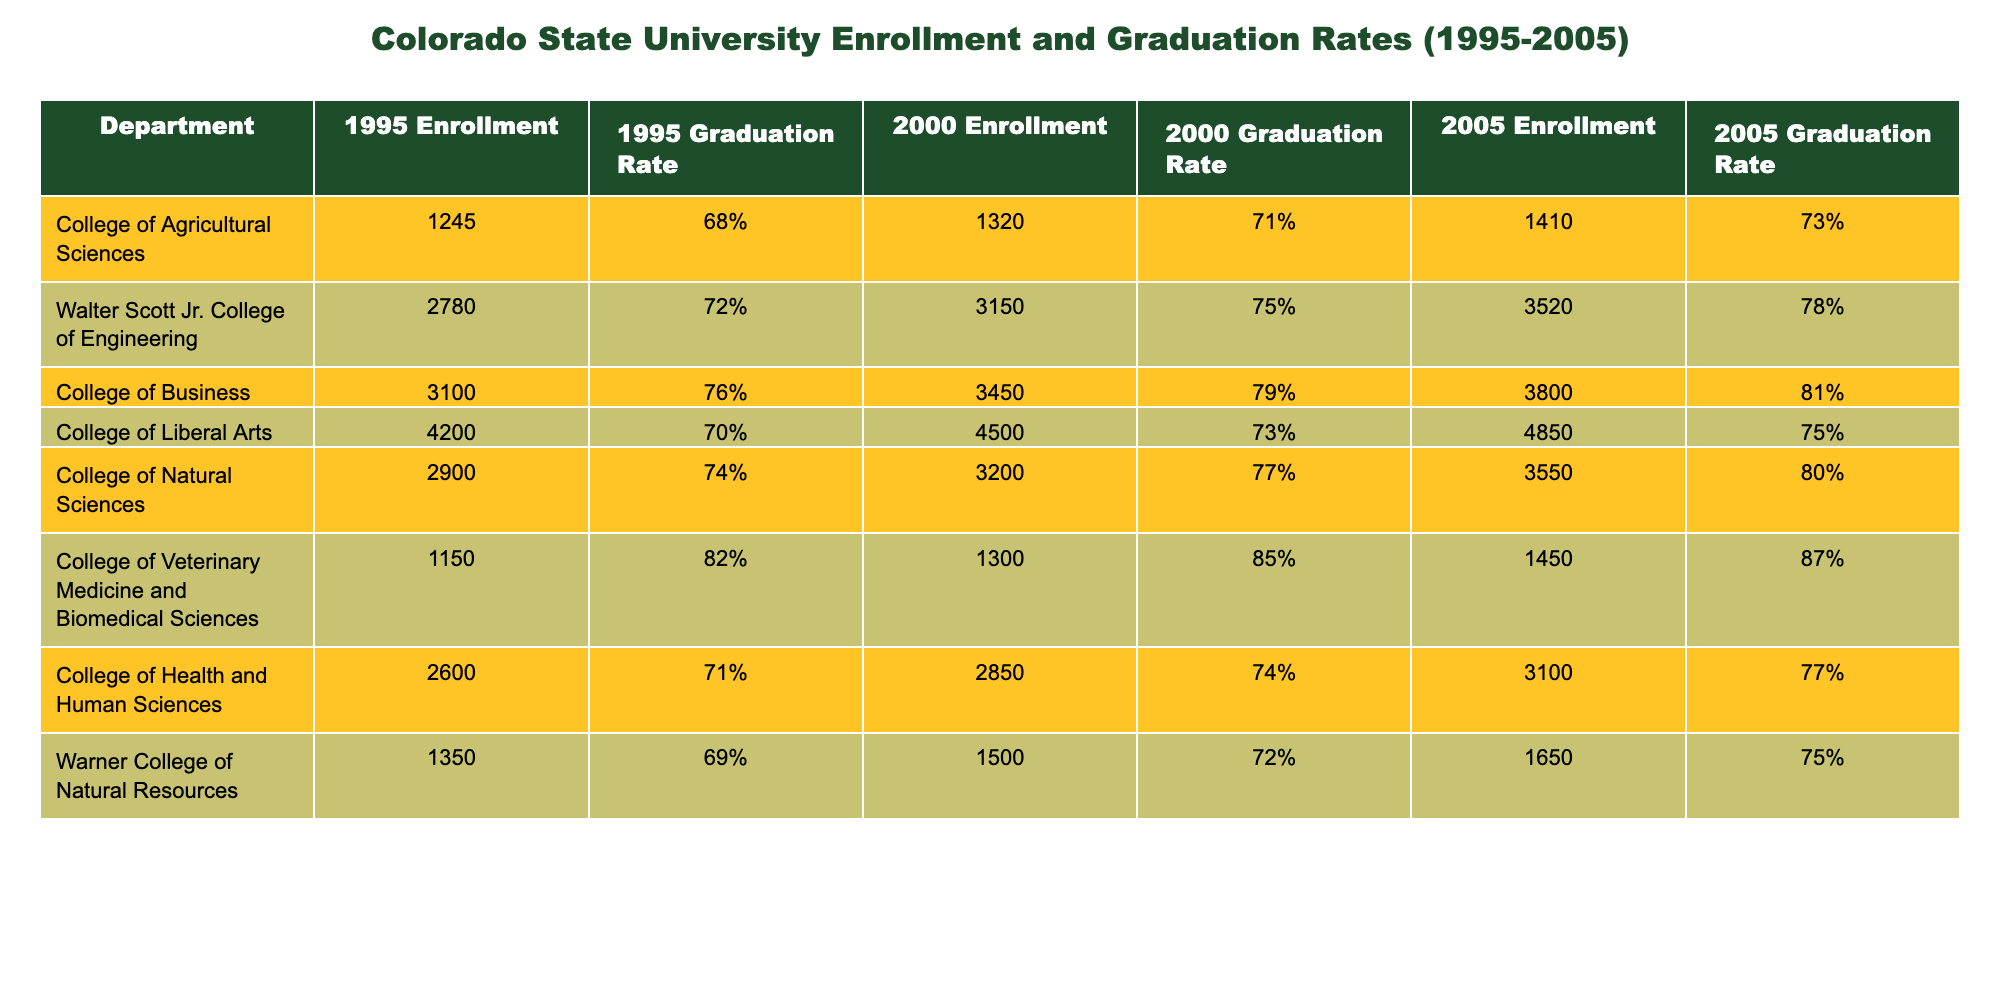What was the enrollment in the College of Business in 2000? The table shows that the enrollment for the College of Business in 2000 is listed under the column for 2000 Enrollment. It states 3450.
Answer: 3450 Which department had the highest graduation rate in 2005? To find the highest graduation rate in 2005, I look at the column for the 2005 Graduation Rate and compare the values. The College of Veterinary Medicine and Biomedical Sciences has a graduation rate of 87%, which is the highest.
Answer: College of Veterinary Medicine and Biomedical Sciences What is the percentage increase in enrollment for the Walter Scott Jr. College of Engineering from 1995 to 2005? First, I take the enrollment numbers: 2780 in 1995 and 3520 in 2005. To calculate the increase, I subtract 2780 from 3520, which gives 740. Then, I divide by the original number (2780) and multiply by 100 to get the percentage: (740 / 2780) * 100 ≈ 26.6%.
Answer: Approximately 26.6% Did the College of Health and Human Sciences have a higher graduation rate in 2000 or in 2005? The graduation rates for the College of Health and Human Sciences are 74% in 2000 and 77% in 2005. Since 77% is greater than 74%, the graduation rate was higher in 2005.
Answer: Yes, higher in 2005 What is the average graduation rate across all departments in 2005? I extract the graduation rates for 2005 from each department: 73%, 78%, 81%, 75%, 80%, 87%, 77%, and 75%. To find the average, I sum these percentages: 73 + 78 + 81 + 75 + 80 + 87 + 77 + 75 = 606. Then, I divide by the number of departments (8): 606 / 8 = 75.75%.
Answer: 75.75% Is it true that the College of Liberal Arts had a lower enrollment in 2005 than in 2000? The enrollment for the College of Liberal Arts is 4500 in 2000 and 4850 in 2005. Since 4850 is greater than 4500, this statement is false.
Answer: No Which department saw the largest increase in graduation rate from 1995 to 2005? By examining the graduation rates for each department over the time from 1995 to 2005, I find the increases: Agricultural Sciences (5%), Engineering (6%), Business (5%), Liberal Arts (5%), Natural Sciences (6%), Veterinary Medicine (5%), Health and Human Sciences (6%), and Warner College (6%). The departments with the largest increase are Engineering, Natural Sciences, and Health and Human Sciences, each increasing by 6%.
Answer: Engineering, Natural Sciences, and Health and Human Sciences How many departments had a graduation rate of at least 80% in 2005? I look at the 2005 Graduation Rate column and count how many departments have rates of 80% or higher: Veterinary Medicine (87%), College of Business (81%), and Walter Scott Jr. College of Engineering (78%) do not meet this criterion, while Natural Sciences (80%) does. Therefore, there are three departments with graduation rates of at least 80%.
Answer: 3 